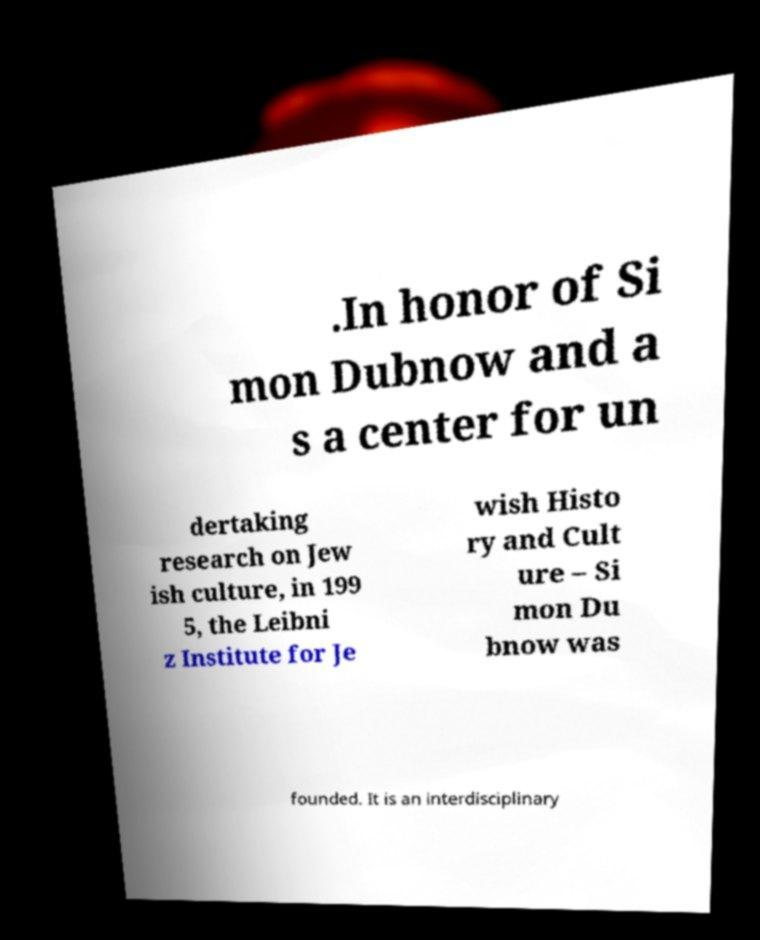What messages or text are displayed in this image? I need them in a readable, typed format. .In honor of Si mon Dubnow and a s a center for un dertaking research on Jew ish culture, in 199 5, the Leibni z Institute for Je wish Histo ry and Cult ure – Si mon Du bnow was founded. It is an interdisciplinary 